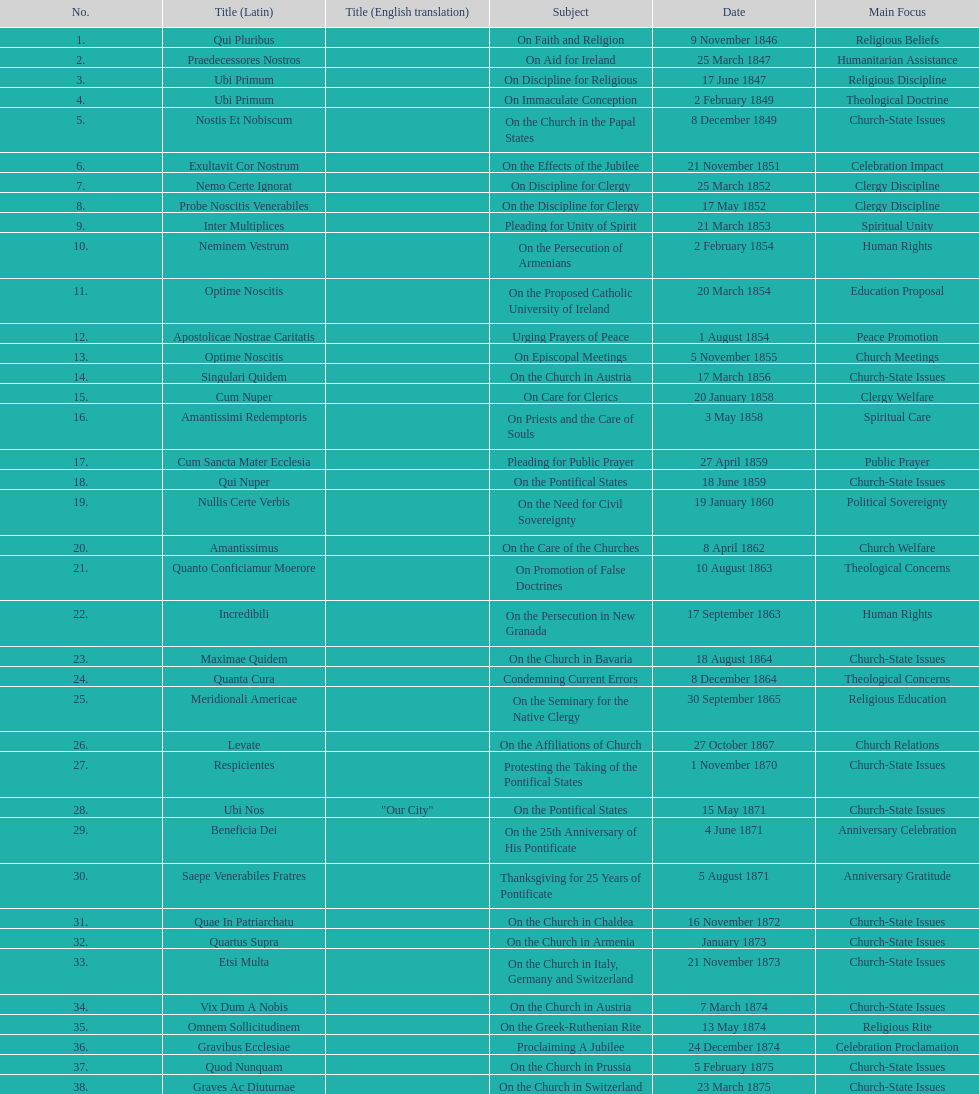How many encyclicals were issued between august 15, 1854 and october 26, 1867? 13. 